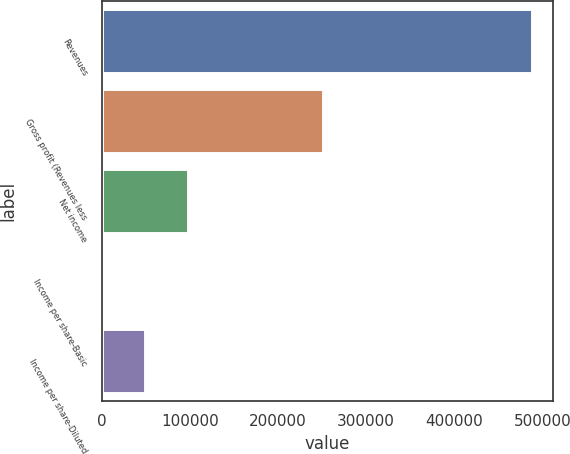<chart> <loc_0><loc_0><loc_500><loc_500><bar_chart><fcel>Revenues<fcel>Gross profit (Revenues less<fcel>Net income<fcel>Income per share-Basic<fcel>Income per share-Diluted<nl><fcel>487739<fcel>251452<fcel>97548<fcel>0.2<fcel>48774.1<nl></chart> 